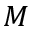<formula> <loc_0><loc_0><loc_500><loc_500>M</formula> 